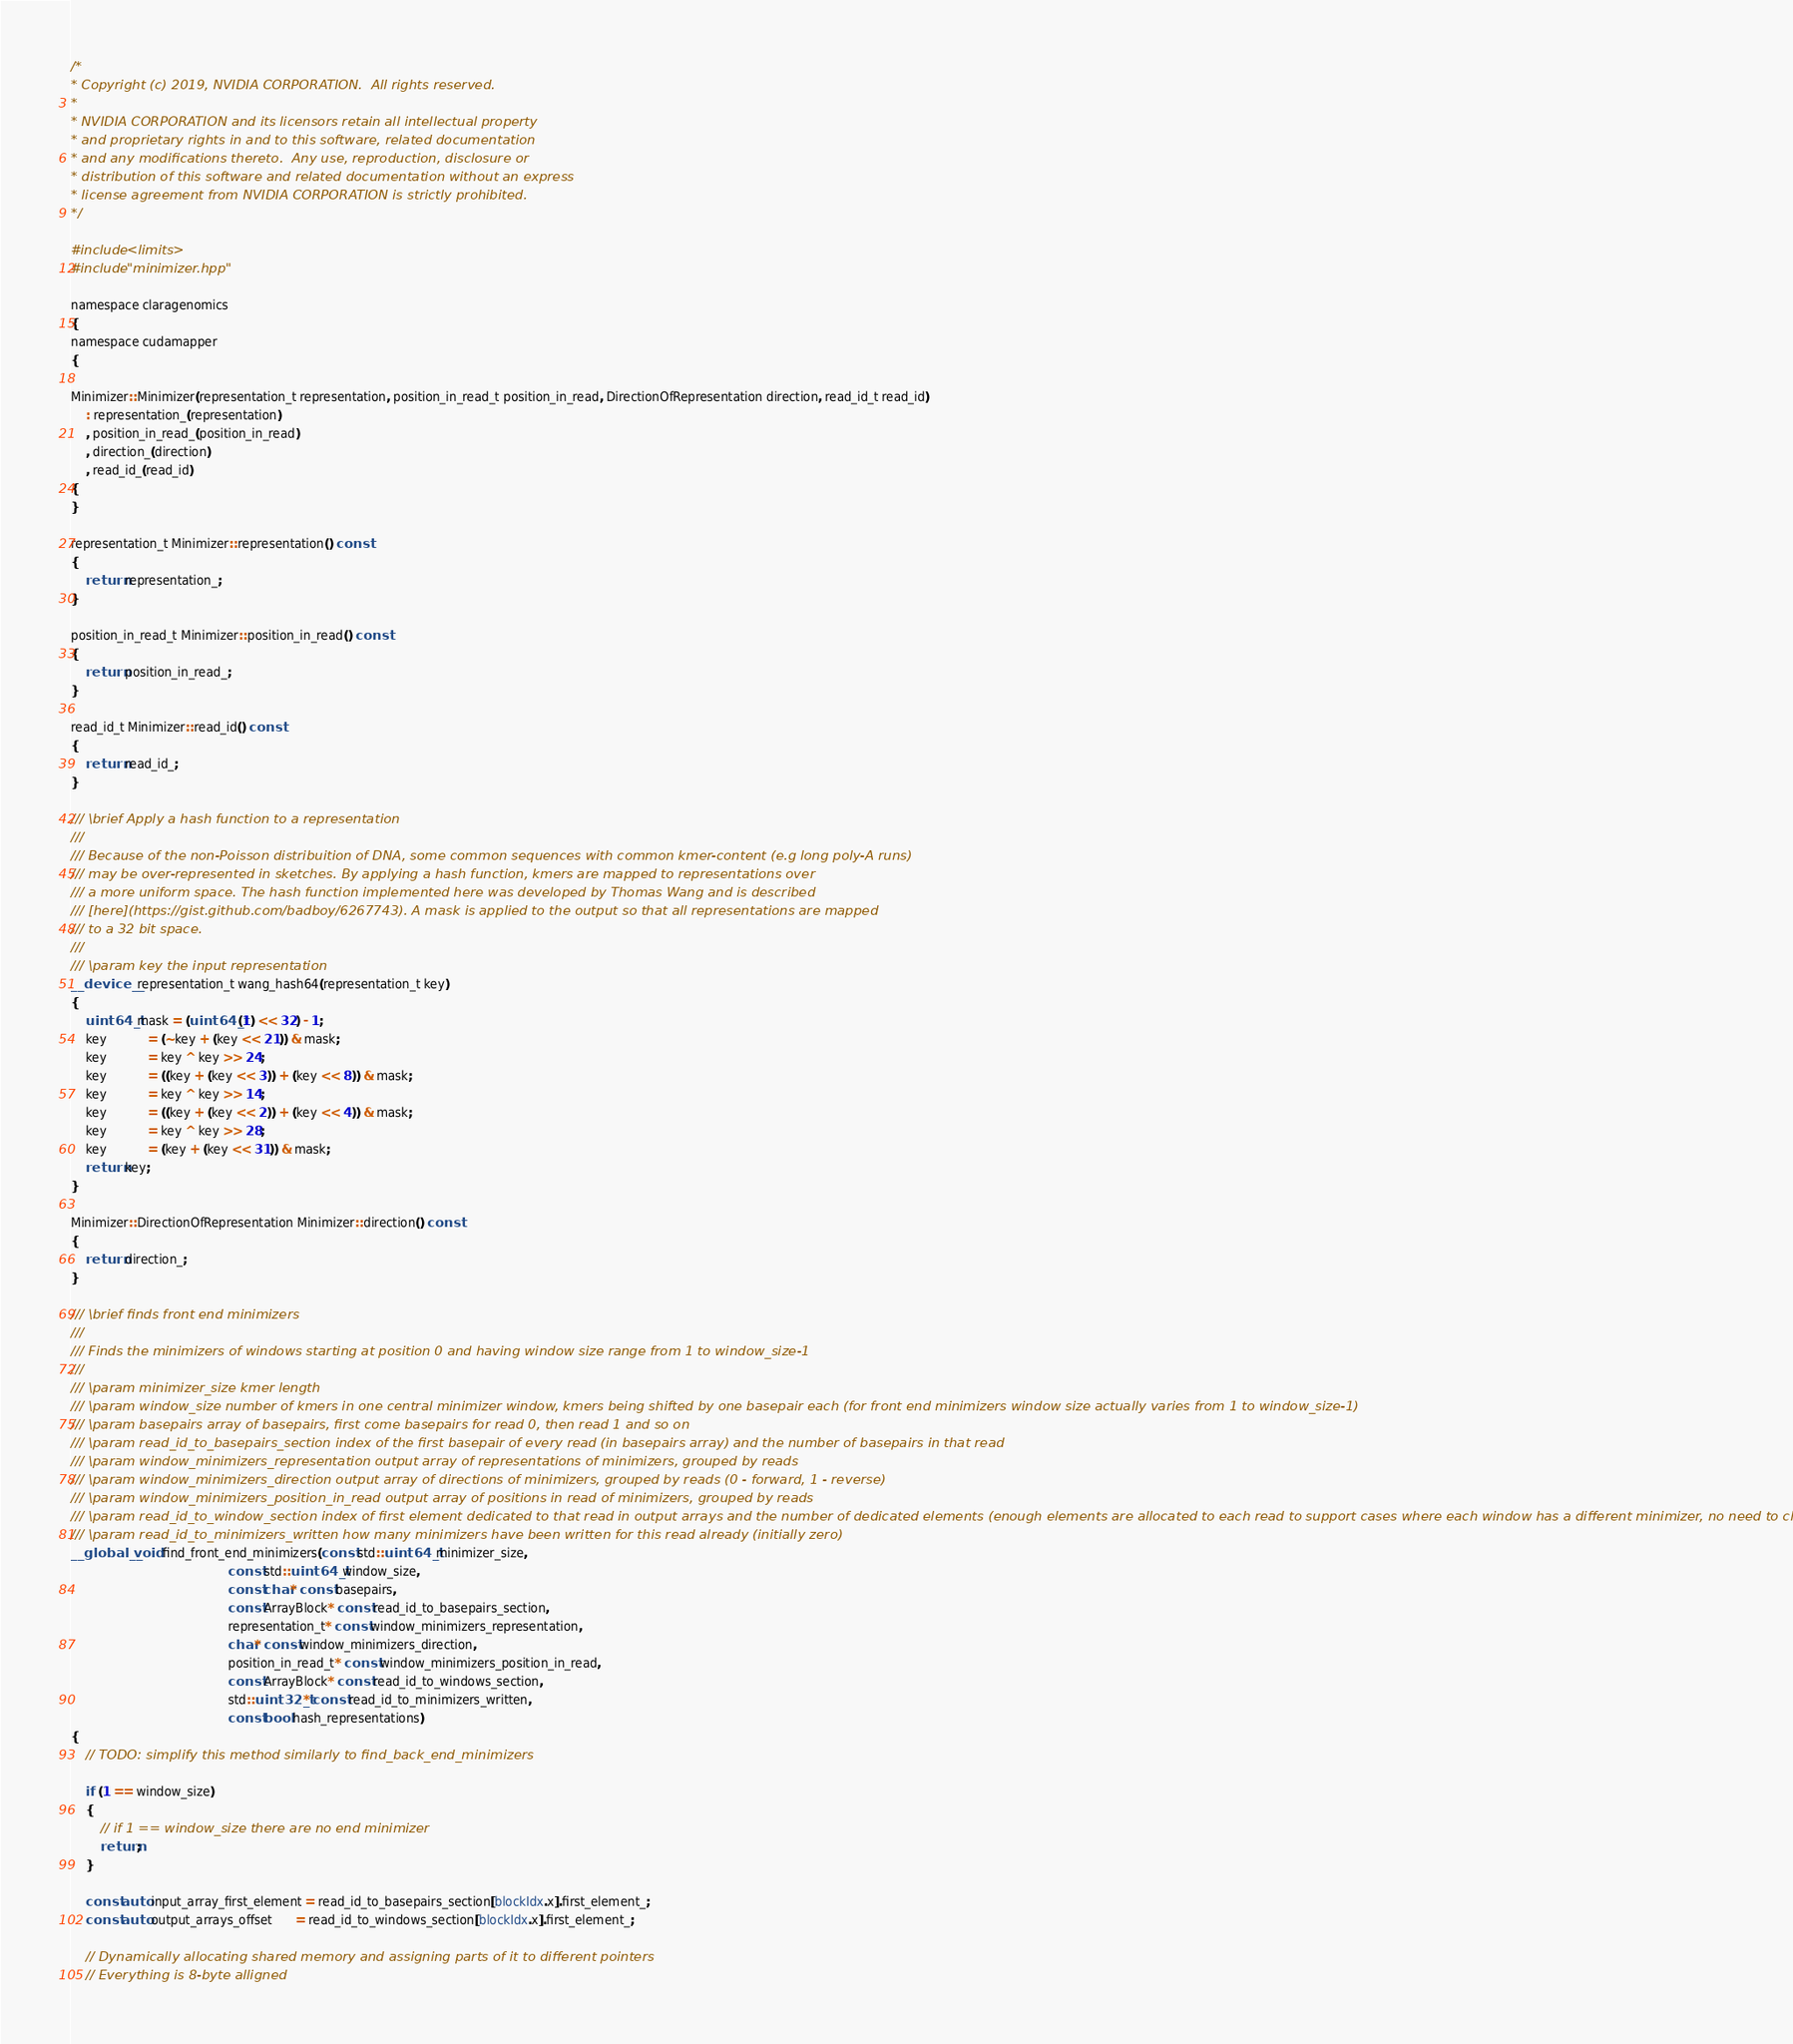<code> <loc_0><loc_0><loc_500><loc_500><_Cuda_>/*
* Copyright (c) 2019, NVIDIA CORPORATION.  All rights reserved.
*
* NVIDIA CORPORATION and its licensors retain all intellectual property
* and proprietary rights in and to this software, related documentation
* and any modifications thereto.  Any use, reproduction, disclosure or
* distribution of this software and related documentation without an express
* license agreement from NVIDIA CORPORATION is strictly prohibited.
*/

#include <limits>
#include "minimizer.hpp"

namespace claragenomics
{
namespace cudamapper
{

Minimizer::Minimizer(representation_t representation, position_in_read_t position_in_read, DirectionOfRepresentation direction, read_id_t read_id)
    : representation_(representation)
    , position_in_read_(position_in_read)
    , direction_(direction)
    , read_id_(read_id)
{
}

representation_t Minimizer::representation() const
{
    return representation_;
}

position_in_read_t Minimizer::position_in_read() const
{
    return position_in_read_;
}

read_id_t Minimizer::read_id() const
{
    return read_id_;
}

/// \brief Apply a hash function to a representation
///
/// Because of the non-Poisson distribuition of DNA, some common sequences with common kmer-content (e.g long poly-A runs)
/// may be over-represented in sketches. By applying a hash function, kmers are mapped to representations over
/// a more uniform space. The hash function implemented here was developed by Thomas Wang and is described
/// [here](https://gist.github.com/badboy/6267743). A mask is applied to the output so that all representations are mapped
/// to a 32 bit space.
///
/// \param key the input representation
__device__ representation_t wang_hash64(representation_t key)
{
    uint64_t mask = (uint64_t(1) << 32) - 1;
    key           = (~key + (key << 21)) & mask;
    key           = key ^ key >> 24;
    key           = ((key + (key << 3)) + (key << 8)) & mask;
    key           = key ^ key >> 14;
    key           = ((key + (key << 2)) + (key << 4)) & mask;
    key           = key ^ key >> 28;
    key           = (key + (key << 31)) & mask;
    return key;
}

Minimizer::DirectionOfRepresentation Minimizer::direction() const
{
    return direction_;
}

/// \brief finds front end minimizers
///
/// Finds the minimizers of windows starting at position 0 and having window size range from 1 to window_size-1
///
/// \param minimizer_size kmer length
/// \param window_size number of kmers in one central minimizer window, kmers being shifted by one basepair each (for front end minimizers window size actually varies from 1 to window_size-1)
/// \param basepairs array of basepairs, first come basepairs for read 0, then read 1 and so on
/// \param read_id_to_basepairs_section index of the first basepair of every read (in basepairs array) and the number of basepairs in that read
/// \param window_minimizers_representation output array of representations of minimizers, grouped by reads
/// \param window_minimizers_direction output array of directions of minimizers, grouped by reads (0 - forward, 1 - reverse)
/// \param window_minimizers_position_in_read output array of positions in read of minimizers, grouped by reads
/// \param read_id_to_window_section index of first element dedicated to that read in output arrays and the number of dedicated elements (enough elements are allocated to each read to support cases where each window has a different minimizer, no need to check that condition)
/// \param read_id_to_minimizers_written how many minimizers have been written for this read already (initially zero)
__global__ void find_front_end_minimizers(const std::uint64_t minimizer_size,
                                          const std::uint64_t window_size,
                                          const char* const basepairs,
                                          const ArrayBlock* const read_id_to_basepairs_section,
                                          representation_t* const window_minimizers_representation,
                                          char* const window_minimizers_direction,
                                          position_in_read_t* const window_minimizers_position_in_read,
                                          const ArrayBlock* const read_id_to_windows_section,
                                          std::uint32_t* const read_id_to_minimizers_written,
                                          const bool hash_representations)
{
    // TODO: simplify this method similarly to find_back_end_minimizers

    if (1 == window_size)
    {
        // if 1 == window_size there are no end minimizer
        return;
    }

    const auto input_array_first_element = read_id_to_basepairs_section[blockIdx.x].first_element_;
    const auto output_arrays_offset      = read_id_to_windows_section[blockIdx.x].first_element_;

    // Dynamically allocating shared memory and assigning parts of it to different pointers
    // Everything is 8-byte alligned</code> 